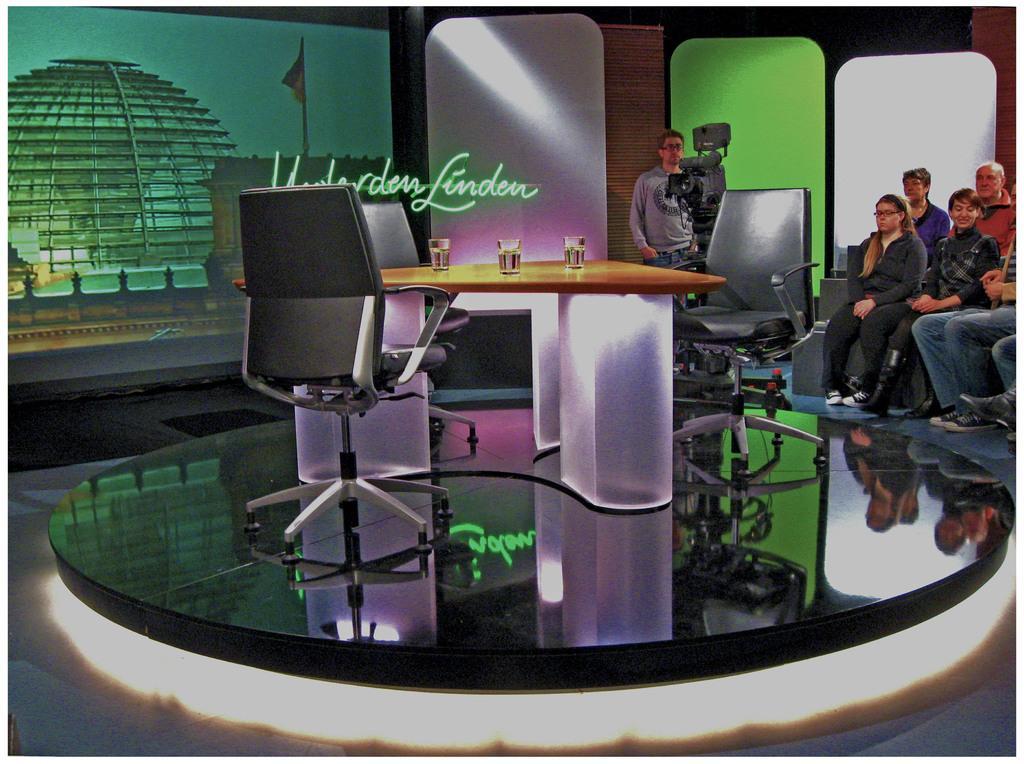Describe this image in one or two sentences. This image consist of a table and chairs. In the background, there are screens. To the right, there is a camera behind which a man is standing. To the right, there are many people sitting. 